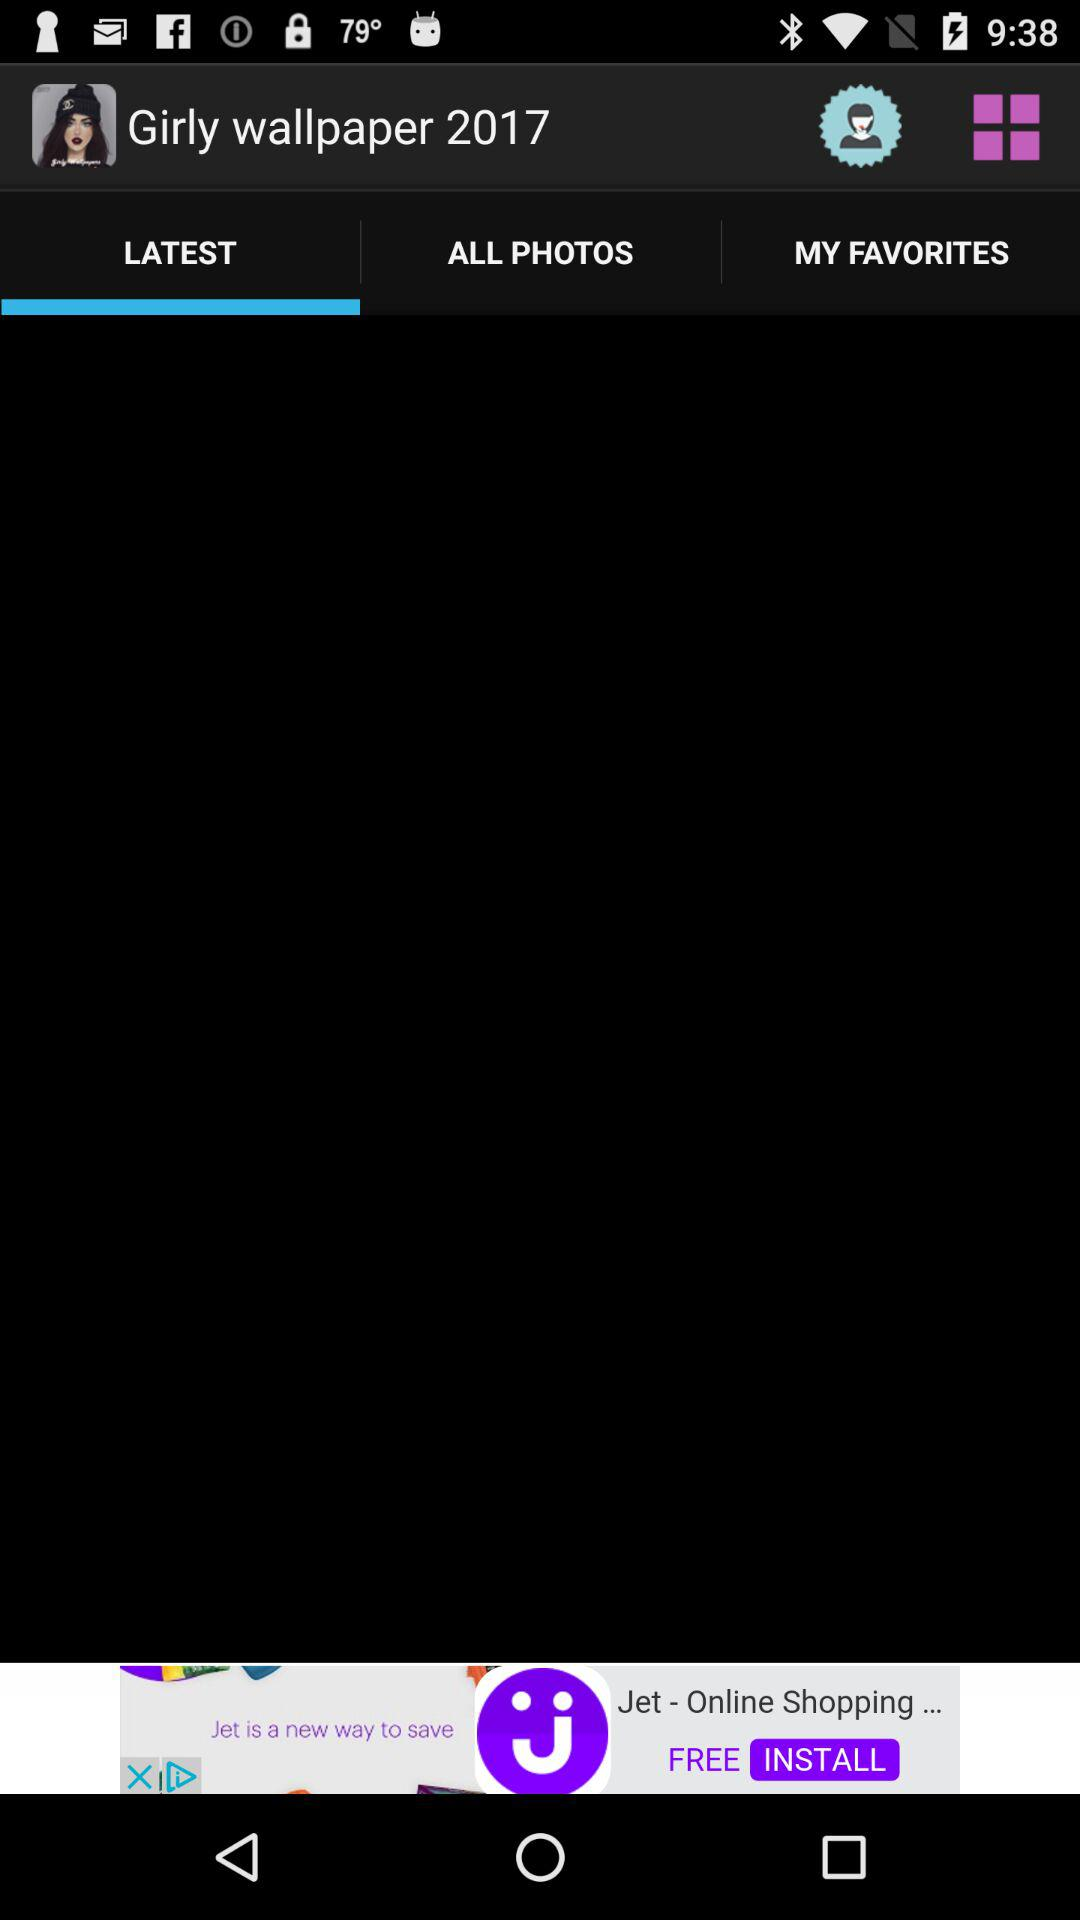Which tab is selected? The selected tab is "LATEST". 